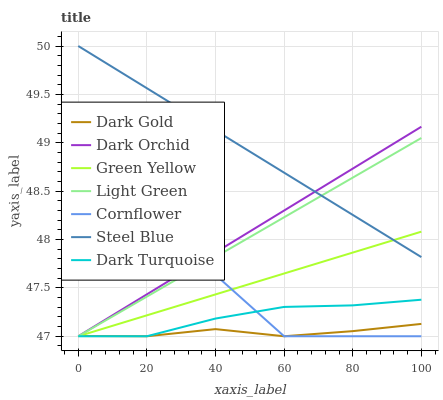Does Dark Turquoise have the minimum area under the curve?
Answer yes or no. No. Does Dark Turquoise have the maximum area under the curve?
Answer yes or no. No. Is Dark Gold the smoothest?
Answer yes or no. No. Is Dark Gold the roughest?
Answer yes or no. No. Does Steel Blue have the lowest value?
Answer yes or no. No. Does Dark Turquoise have the highest value?
Answer yes or no. No. Is Cornflower less than Steel Blue?
Answer yes or no. Yes. Is Steel Blue greater than Dark Gold?
Answer yes or no. Yes. Does Cornflower intersect Steel Blue?
Answer yes or no. No. 